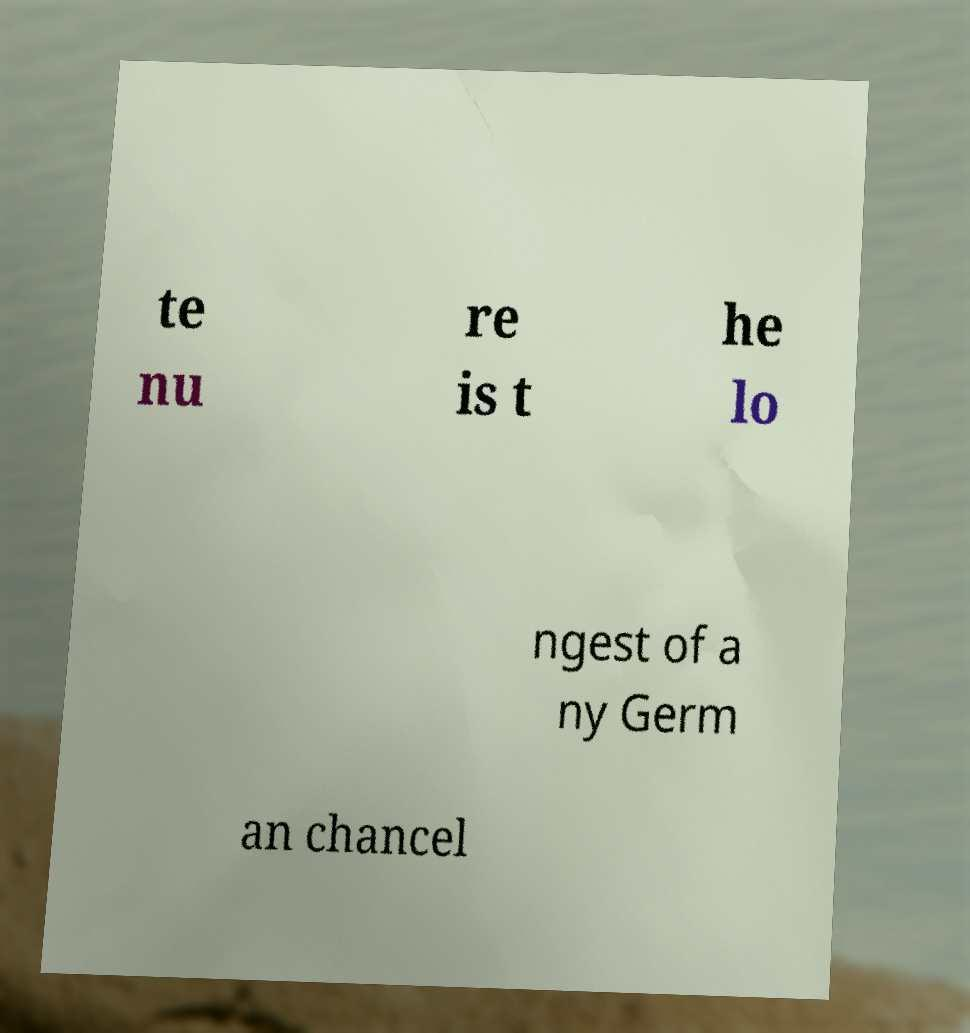Can you accurately transcribe the text from the provided image for me? te nu re is t he lo ngest of a ny Germ an chancel 